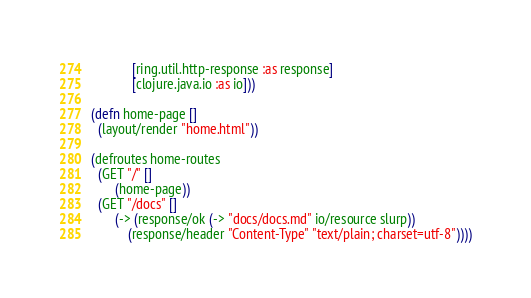<code> <loc_0><loc_0><loc_500><loc_500><_Clojure_>            [ring.util.http-response :as response]
            [clojure.java.io :as io]))

(defn home-page []
  (layout/render "home.html"))

(defroutes home-routes
  (GET "/" []
       (home-page))
  (GET "/docs" []
       (-> (response/ok (-> "docs/docs.md" io/resource slurp))
           (response/header "Content-Type" "text/plain; charset=utf-8"))))

</code> 